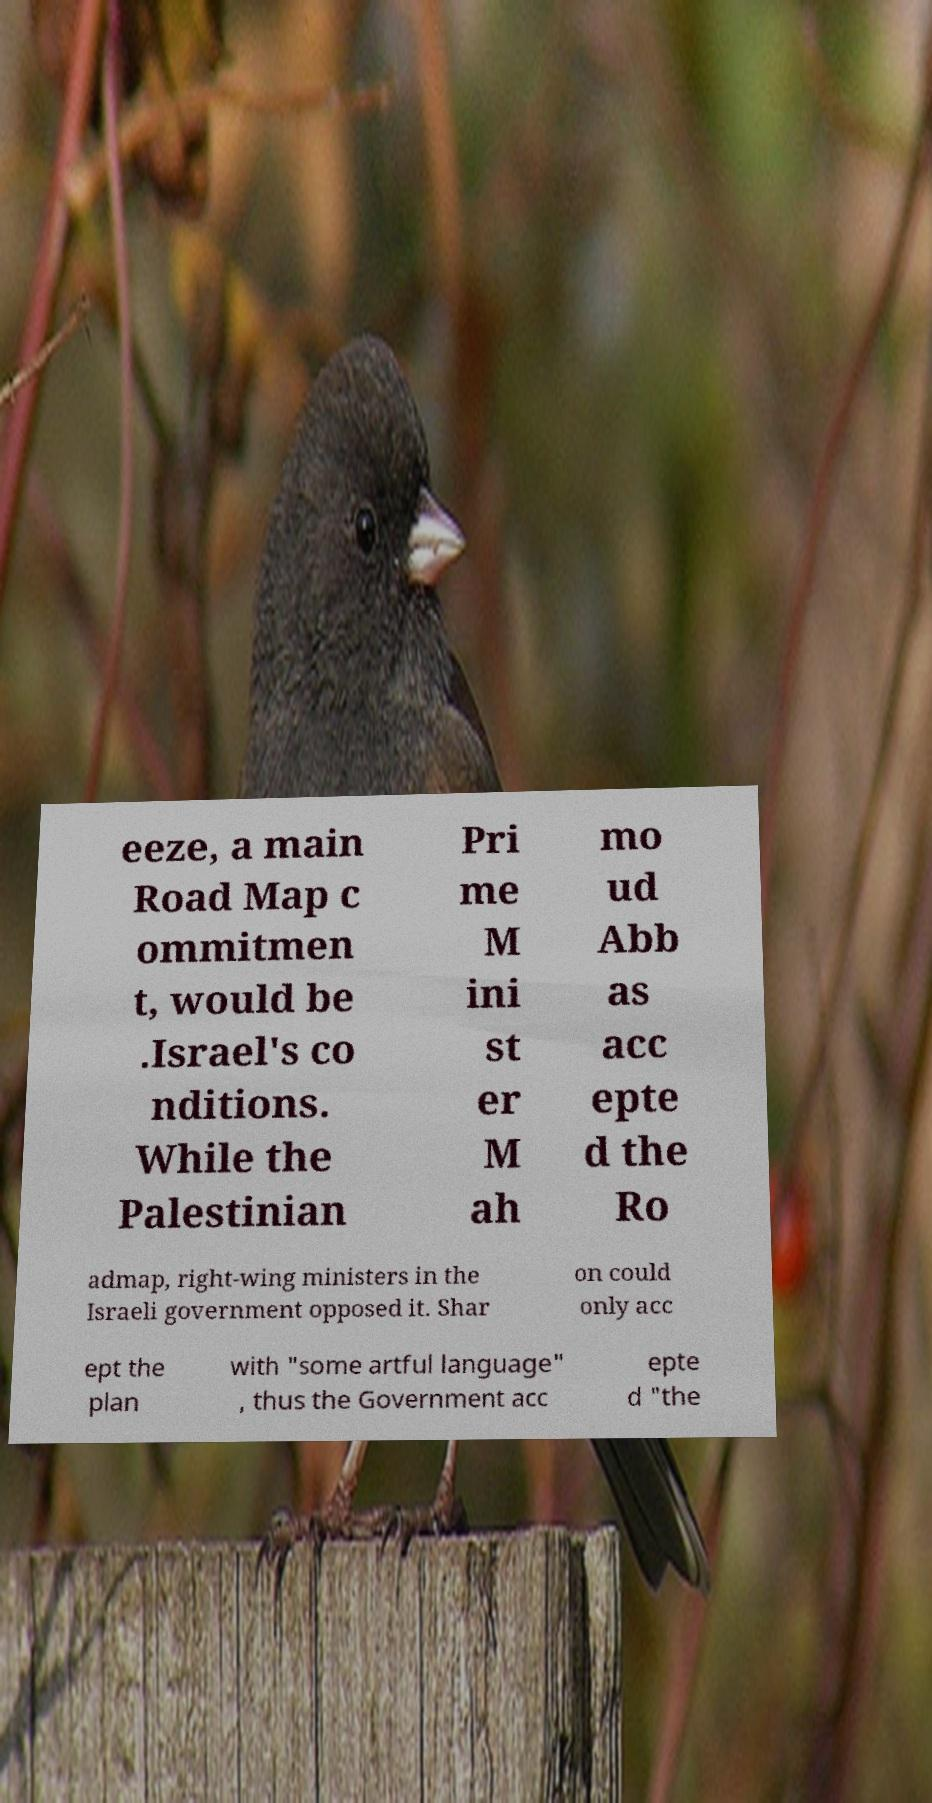Could you assist in decoding the text presented in this image and type it out clearly? eeze, a main Road Map c ommitmen t, would be .Israel's co nditions. While the Palestinian Pri me M ini st er M ah mo ud Abb as acc epte d the Ro admap, right-wing ministers in the Israeli government opposed it. Shar on could only acc ept the plan with "some artful language" , thus the Government acc epte d "the 